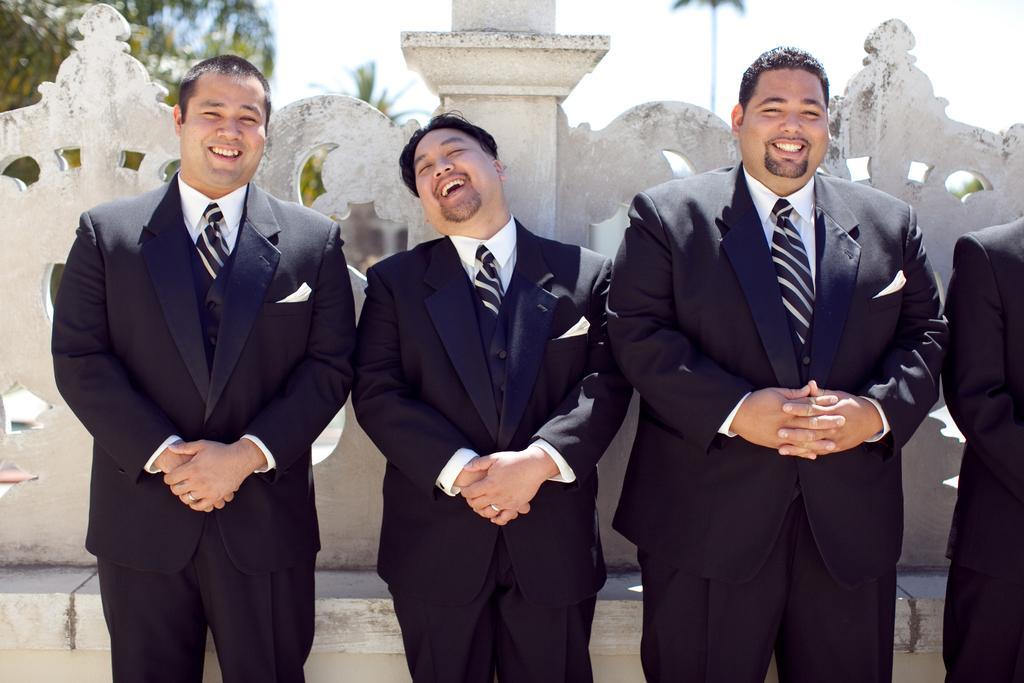Describe this image in one or two sentences. In this picture we can see group of people, they are all smiling, and they wore black color suits, in the background we can see few trees. 